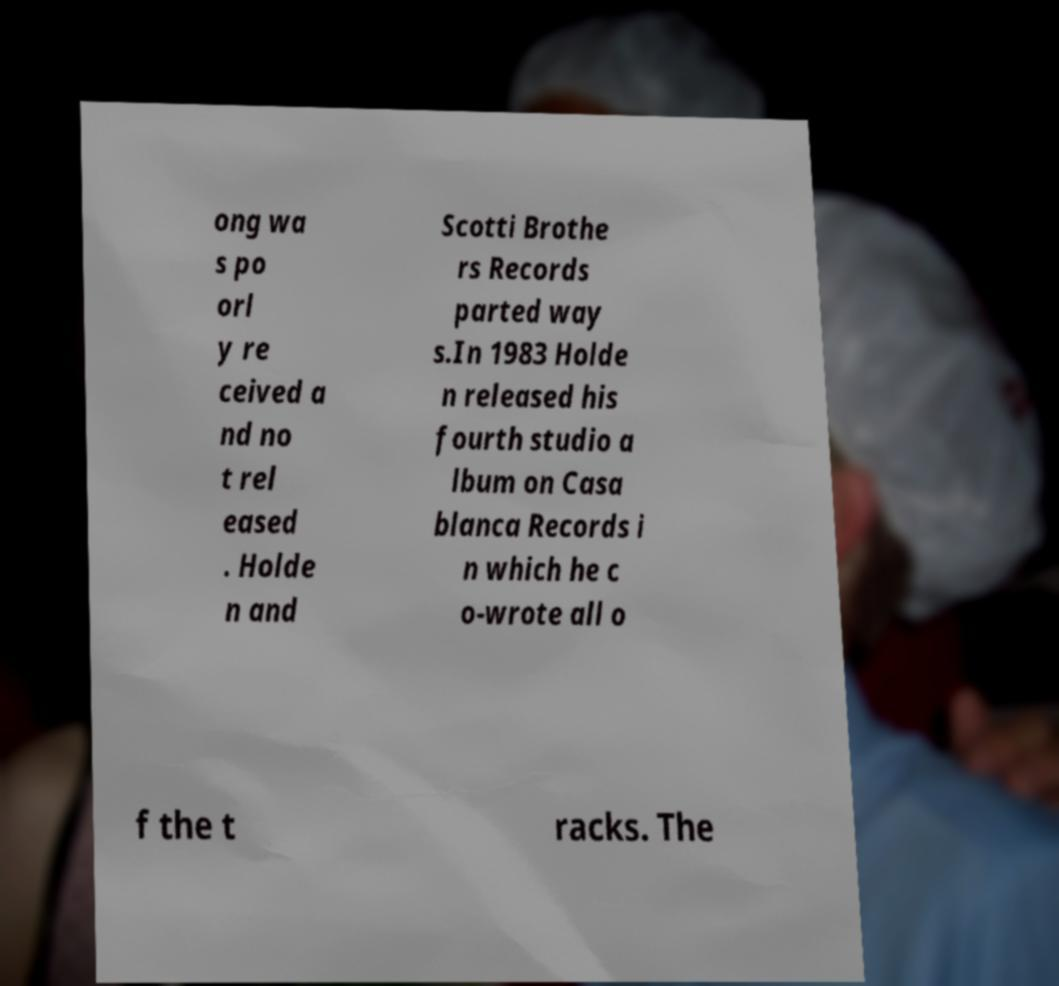Please read and relay the text visible in this image. What does it say? ong wa s po orl y re ceived a nd no t rel eased . Holde n and Scotti Brothe rs Records parted way s.In 1983 Holde n released his fourth studio a lbum on Casa blanca Records i n which he c o-wrote all o f the t racks. The 